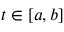Convert formula to latex. <formula><loc_0><loc_0><loc_500><loc_500>t \in [ a , b ]</formula> 